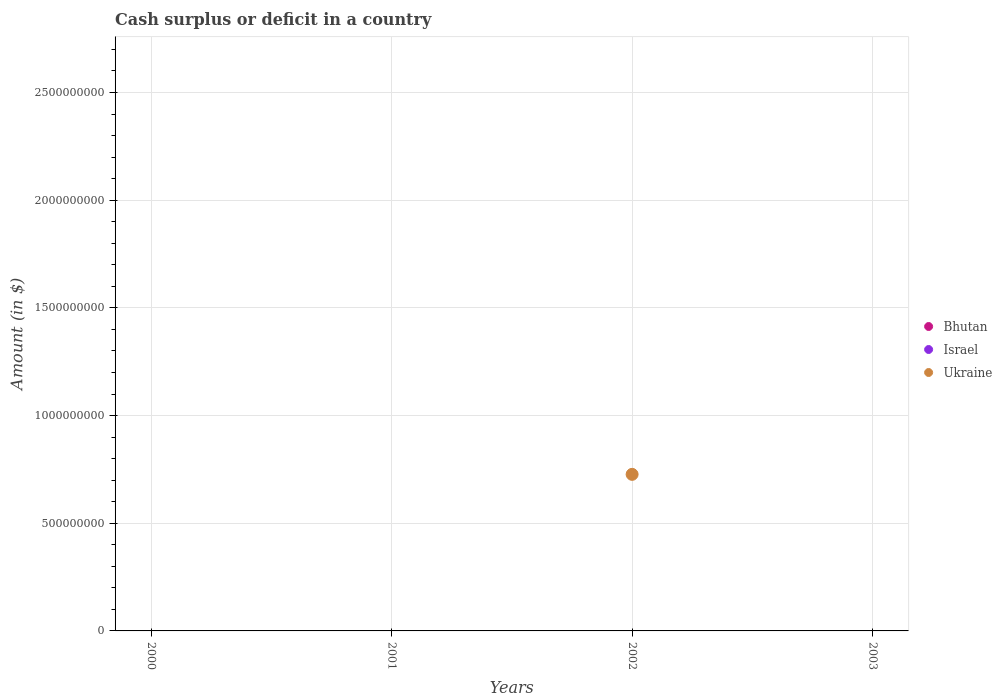What is the amount of cash surplus or deficit in Ukraine in 2002?
Ensure brevity in your answer.  7.27e+08. Across all years, what is the maximum amount of cash surplus or deficit in Ukraine?
Provide a short and direct response. 7.27e+08. In which year was the amount of cash surplus or deficit in Ukraine maximum?
Offer a terse response. 2002. What is the total amount of cash surplus or deficit in Ukraine in the graph?
Your response must be concise. 7.27e+08. What is the difference between the amount of cash surplus or deficit in Israel in 2000 and the amount of cash surplus or deficit in Bhutan in 2001?
Provide a short and direct response. 0. What is the average amount of cash surplus or deficit in Ukraine per year?
Provide a succinct answer. 1.82e+08. In how many years, is the amount of cash surplus or deficit in Bhutan greater than 100000000 $?
Offer a terse response. 0. What is the difference between the highest and the lowest amount of cash surplus or deficit in Ukraine?
Your response must be concise. 7.27e+08. Does the amount of cash surplus or deficit in Israel monotonically increase over the years?
Keep it short and to the point. No. Is the amount of cash surplus or deficit in Ukraine strictly greater than the amount of cash surplus or deficit in Bhutan over the years?
Offer a very short reply. No. How many dotlines are there?
Ensure brevity in your answer.  1. How many years are there in the graph?
Your answer should be very brief. 4. Does the graph contain any zero values?
Offer a terse response. Yes. What is the title of the graph?
Offer a terse response. Cash surplus or deficit in a country. What is the label or title of the Y-axis?
Ensure brevity in your answer.  Amount (in $). What is the Amount (in $) of Ukraine in 2000?
Give a very brief answer. 0. What is the Amount (in $) in Israel in 2001?
Provide a succinct answer. 0. What is the Amount (in $) of Bhutan in 2002?
Your answer should be compact. 0. What is the Amount (in $) of Israel in 2002?
Give a very brief answer. 0. What is the Amount (in $) in Ukraine in 2002?
Give a very brief answer. 7.27e+08. What is the Amount (in $) of Bhutan in 2003?
Keep it short and to the point. 0. What is the Amount (in $) in Israel in 2003?
Keep it short and to the point. 0. Across all years, what is the maximum Amount (in $) of Ukraine?
Give a very brief answer. 7.27e+08. Across all years, what is the minimum Amount (in $) in Ukraine?
Offer a very short reply. 0. What is the total Amount (in $) in Bhutan in the graph?
Your answer should be very brief. 0. What is the total Amount (in $) of Ukraine in the graph?
Your answer should be compact. 7.27e+08. What is the average Amount (in $) in Israel per year?
Ensure brevity in your answer.  0. What is the average Amount (in $) of Ukraine per year?
Offer a terse response. 1.82e+08. What is the difference between the highest and the lowest Amount (in $) in Ukraine?
Make the answer very short. 7.27e+08. 